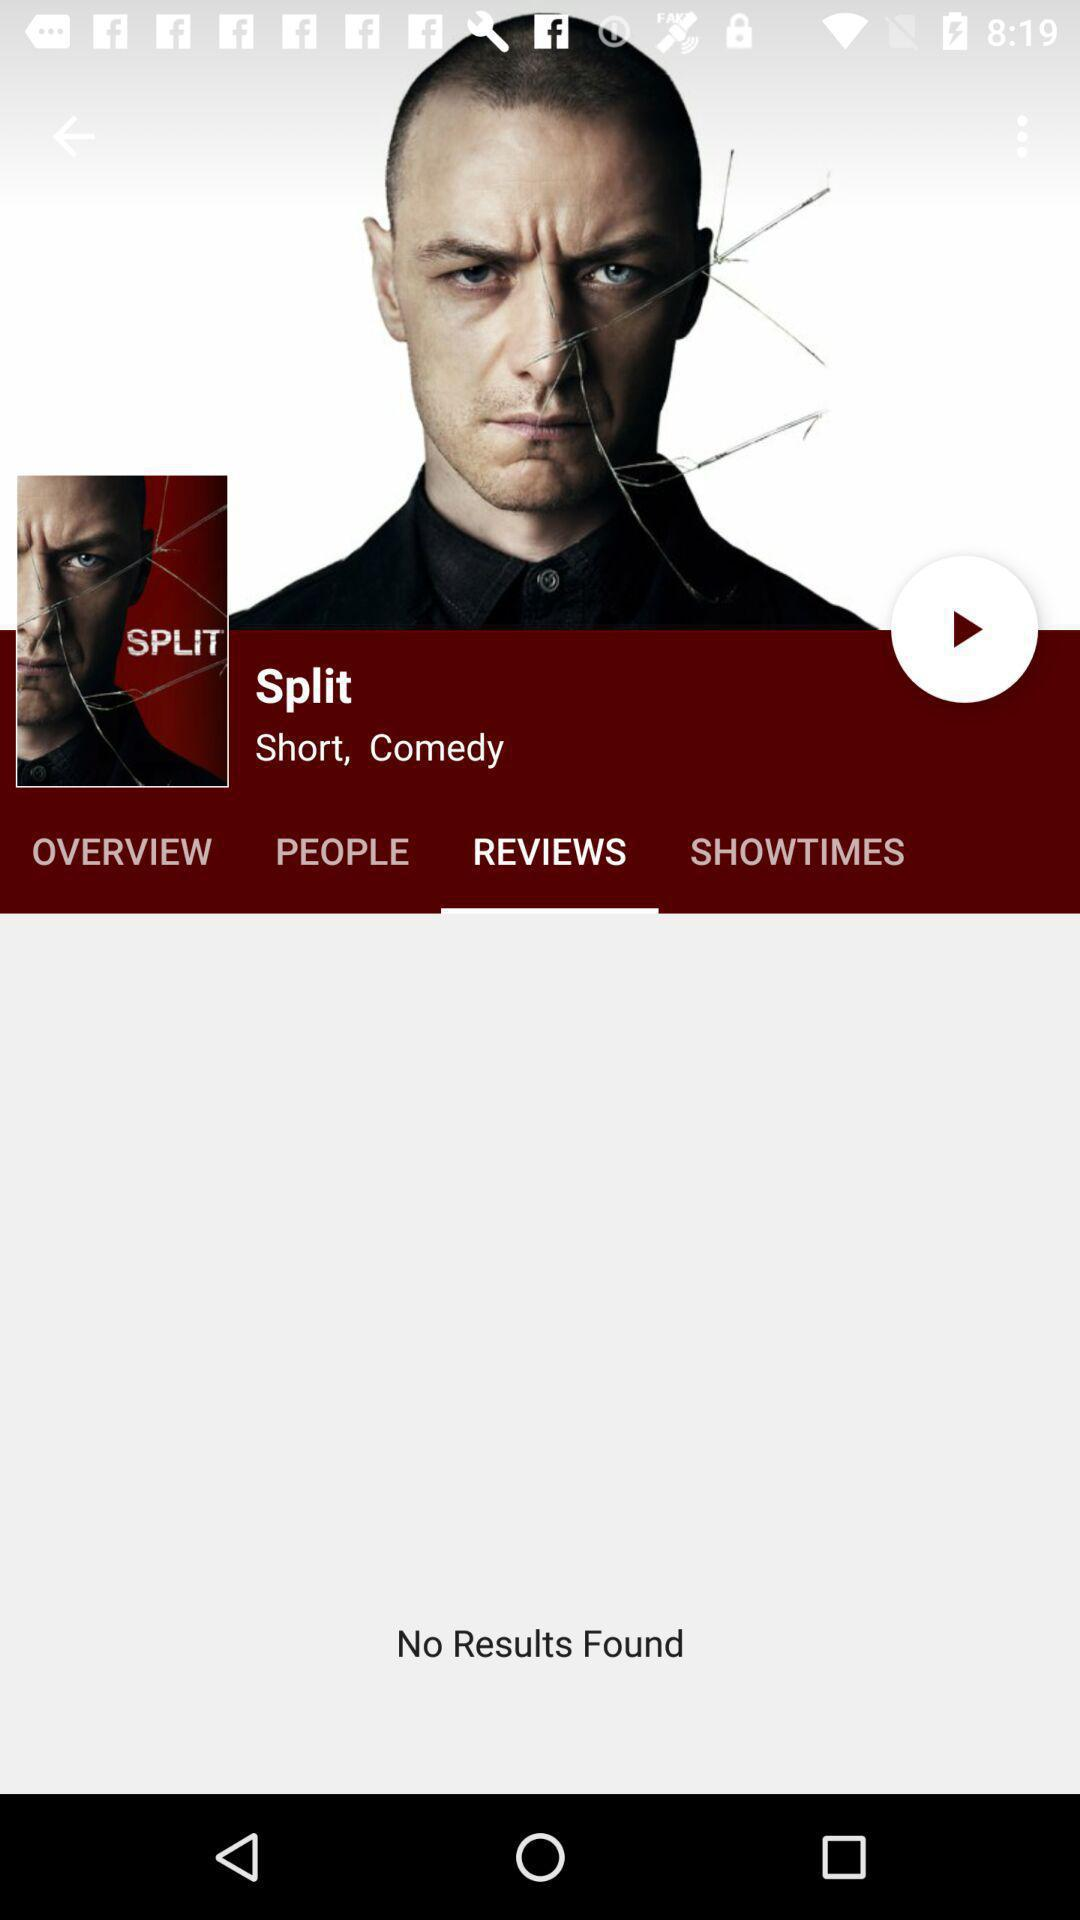Which is the currently selected tab? The currently selected tab is "REVIEWS". 